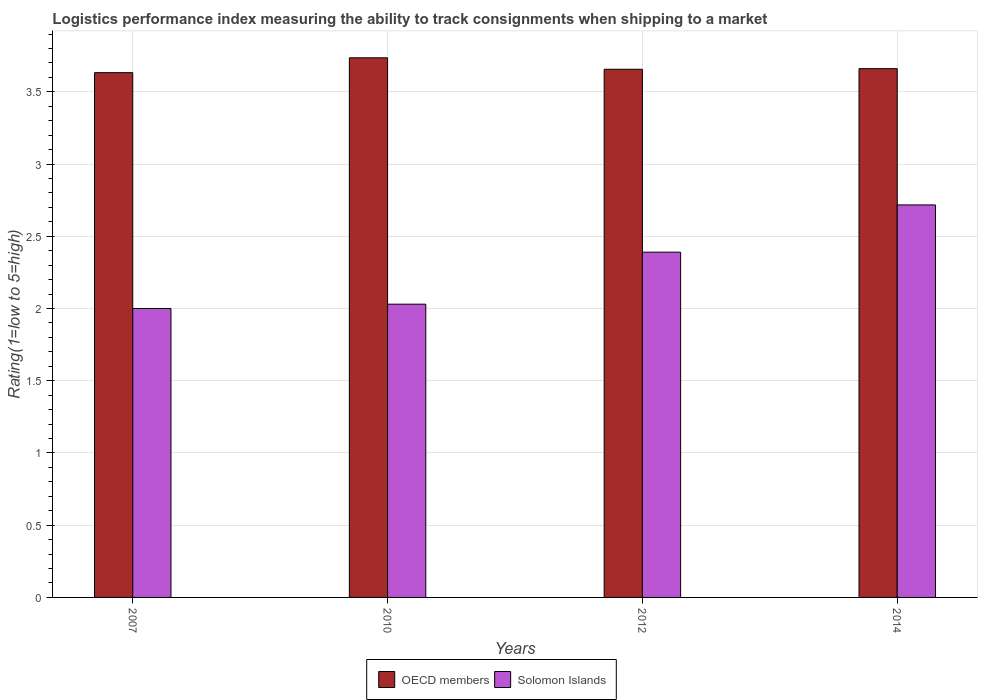How many groups of bars are there?
Make the answer very short. 4. Are the number of bars per tick equal to the number of legend labels?
Offer a very short reply. Yes. Are the number of bars on each tick of the X-axis equal?
Keep it short and to the point. Yes. How many bars are there on the 2nd tick from the left?
Provide a succinct answer. 2. How many bars are there on the 1st tick from the right?
Offer a very short reply. 2. What is the Logistic performance index in OECD members in 2010?
Your answer should be compact. 3.74. Across all years, what is the maximum Logistic performance index in Solomon Islands?
Your response must be concise. 2.72. Across all years, what is the minimum Logistic performance index in OECD members?
Your answer should be compact. 3.63. In which year was the Logistic performance index in OECD members maximum?
Your answer should be compact. 2010. What is the total Logistic performance index in OECD members in the graph?
Keep it short and to the point. 14.69. What is the difference between the Logistic performance index in Solomon Islands in 2007 and that in 2014?
Provide a short and direct response. -0.72. What is the difference between the Logistic performance index in Solomon Islands in 2010 and the Logistic performance index in OECD members in 2014?
Provide a short and direct response. -1.63. What is the average Logistic performance index in OECD members per year?
Provide a succinct answer. 3.67. In the year 2012, what is the difference between the Logistic performance index in OECD members and Logistic performance index in Solomon Islands?
Make the answer very short. 1.27. In how many years, is the Logistic performance index in OECD members greater than 2.4?
Provide a succinct answer. 4. What is the ratio of the Logistic performance index in OECD members in 2007 to that in 2010?
Your response must be concise. 0.97. What is the difference between the highest and the second highest Logistic performance index in Solomon Islands?
Your answer should be compact. 0.33. What is the difference between the highest and the lowest Logistic performance index in Solomon Islands?
Your response must be concise. 0.72. What does the 2nd bar from the left in 2012 represents?
Ensure brevity in your answer.  Solomon Islands. What is the difference between two consecutive major ticks on the Y-axis?
Your answer should be very brief. 0.5. Are the values on the major ticks of Y-axis written in scientific E-notation?
Provide a succinct answer. No. What is the title of the graph?
Offer a terse response. Logistics performance index measuring the ability to track consignments when shipping to a market. What is the label or title of the Y-axis?
Your response must be concise. Rating(1=low to 5=high). What is the Rating(1=low to 5=high) in OECD members in 2007?
Provide a succinct answer. 3.63. What is the Rating(1=low to 5=high) of Solomon Islands in 2007?
Provide a succinct answer. 2. What is the Rating(1=low to 5=high) in OECD members in 2010?
Ensure brevity in your answer.  3.74. What is the Rating(1=low to 5=high) in Solomon Islands in 2010?
Provide a succinct answer. 2.03. What is the Rating(1=low to 5=high) in OECD members in 2012?
Provide a short and direct response. 3.66. What is the Rating(1=low to 5=high) in Solomon Islands in 2012?
Offer a very short reply. 2.39. What is the Rating(1=low to 5=high) of OECD members in 2014?
Offer a terse response. 3.66. What is the Rating(1=low to 5=high) in Solomon Islands in 2014?
Your answer should be compact. 2.72. Across all years, what is the maximum Rating(1=low to 5=high) in OECD members?
Your response must be concise. 3.74. Across all years, what is the maximum Rating(1=low to 5=high) of Solomon Islands?
Give a very brief answer. 2.72. Across all years, what is the minimum Rating(1=low to 5=high) of OECD members?
Your response must be concise. 3.63. What is the total Rating(1=low to 5=high) of OECD members in the graph?
Your response must be concise. 14.69. What is the total Rating(1=low to 5=high) in Solomon Islands in the graph?
Your answer should be very brief. 9.14. What is the difference between the Rating(1=low to 5=high) of OECD members in 2007 and that in 2010?
Provide a succinct answer. -0.1. What is the difference between the Rating(1=low to 5=high) of Solomon Islands in 2007 and that in 2010?
Offer a very short reply. -0.03. What is the difference between the Rating(1=low to 5=high) in OECD members in 2007 and that in 2012?
Offer a very short reply. -0.02. What is the difference between the Rating(1=low to 5=high) of Solomon Islands in 2007 and that in 2012?
Offer a terse response. -0.39. What is the difference between the Rating(1=low to 5=high) of OECD members in 2007 and that in 2014?
Provide a short and direct response. -0.03. What is the difference between the Rating(1=low to 5=high) of Solomon Islands in 2007 and that in 2014?
Your answer should be compact. -0.72. What is the difference between the Rating(1=low to 5=high) of OECD members in 2010 and that in 2012?
Your response must be concise. 0.08. What is the difference between the Rating(1=low to 5=high) in Solomon Islands in 2010 and that in 2012?
Ensure brevity in your answer.  -0.36. What is the difference between the Rating(1=low to 5=high) of OECD members in 2010 and that in 2014?
Keep it short and to the point. 0.08. What is the difference between the Rating(1=low to 5=high) of Solomon Islands in 2010 and that in 2014?
Give a very brief answer. -0.69. What is the difference between the Rating(1=low to 5=high) of OECD members in 2012 and that in 2014?
Provide a succinct answer. -0. What is the difference between the Rating(1=low to 5=high) of Solomon Islands in 2012 and that in 2014?
Keep it short and to the point. -0.33. What is the difference between the Rating(1=low to 5=high) of OECD members in 2007 and the Rating(1=low to 5=high) of Solomon Islands in 2010?
Make the answer very short. 1.6. What is the difference between the Rating(1=low to 5=high) in OECD members in 2007 and the Rating(1=low to 5=high) in Solomon Islands in 2012?
Your answer should be compact. 1.24. What is the difference between the Rating(1=low to 5=high) of OECD members in 2007 and the Rating(1=low to 5=high) of Solomon Islands in 2014?
Offer a very short reply. 0.92. What is the difference between the Rating(1=low to 5=high) in OECD members in 2010 and the Rating(1=low to 5=high) in Solomon Islands in 2012?
Ensure brevity in your answer.  1.35. What is the difference between the Rating(1=low to 5=high) in OECD members in 2010 and the Rating(1=low to 5=high) in Solomon Islands in 2014?
Your response must be concise. 1.02. What is the difference between the Rating(1=low to 5=high) of OECD members in 2012 and the Rating(1=low to 5=high) of Solomon Islands in 2014?
Your answer should be compact. 0.94. What is the average Rating(1=low to 5=high) in OECD members per year?
Ensure brevity in your answer.  3.67. What is the average Rating(1=low to 5=high) in Solomon Islands per year?
Give a very brief answer. 2.28. In the year 2007, what is the difference between the Rating(1=low to 5=high) in OECD members and Rating(1=low to 5=high) in Solomon Islands?
Provide a short and direct response. 1.63. In the year 2010, what is the difference between the Rating(1=low to 5=high) of OECD members and Rating(1=low to 5=high) of Solomon Islands?
Your response must be concise. 1.71. In the year 2012, what is the difference between the Rating(1=low to 5=high) in OECD members and Rating(1=low to 5=high) in Solomon Islands?
Provide a succinct answer. 1.27. In the year 2014, what is the difference between the Rating(1=low to 5=high) of OECD members and Rating(1=low to 5=high) of Solomon Islands?
Provide a short and direct response. 0.94. What is the ratio of the Rating(1=low to 5=high) of OECD members in 2007 to that in 2010?
Provide a short and direct response. 0.97. What is the ratio of the Rating(1=low to 5=high) of Solomon Islands in 2007 to that in 2010?
Offer a terse response. 0.99. What is the ratio of the Rating(1=low to 5=high) of OECD members in 2007 to that in 2012?
Ensure brevity in your answer.  0.99. What is the ratio of the Rating(1=low to 5=high) in Solomon Islands in 2007 to that in 2012?
Provide a short and direct response. 0.84. What is the ratio of the Rating(1=low to 5=high) of Solomon Islands in 2007 to that in 2014?
Ensure brevity in your answer.  0.74. What is the ratio of the Rating(1=low to 5=high) in OECD members in 2010 to that in 2012?
Offer a very short reply. 1.02. What is the ratio of the Rating(1=low to 5=high) in Solomon Islands in 2010 to that in 2012?
Ensure brevity in your answer.  0.85. What is the ratio of the Rating(1=low to 5=high) in OECD members in 2010 to that in 2014?
Ensure brevity in your answer.  1.02. What is the ratio of the Rating(1=low to 5=high) of Solomon Islands in 2010 to that in 2014?
Your answer should be very brief. 0.75. What is the ratio of the Rating(1=low to 5=high) of OECD members in 2012 to that in 2014?
Ensure brevity in your answer.  1. What is the ratio of the Rating(1=low to 5=high) in Solomon Islands in 2012 to that in 2014?
Give a very brief answer. 0.88. What is the difference between the highest and the second highest Rating(1=low to 5=high) in OECD members?
Give a very brief answer. 0.08. What is the difference between the highest and the second highest Rating(1=low to 5=high) in Solomon Islands?
Your response must be concise. 0.33. What is the difference between the highest and the lowest Rating(1=low to 5=high) of OECD members?
Your answer should be very brief. 0.1. What is the difference between the highest and the lowest Rating(1=low to 5=high) of Solomon Islands?
Your response must be concise. 0.72. 